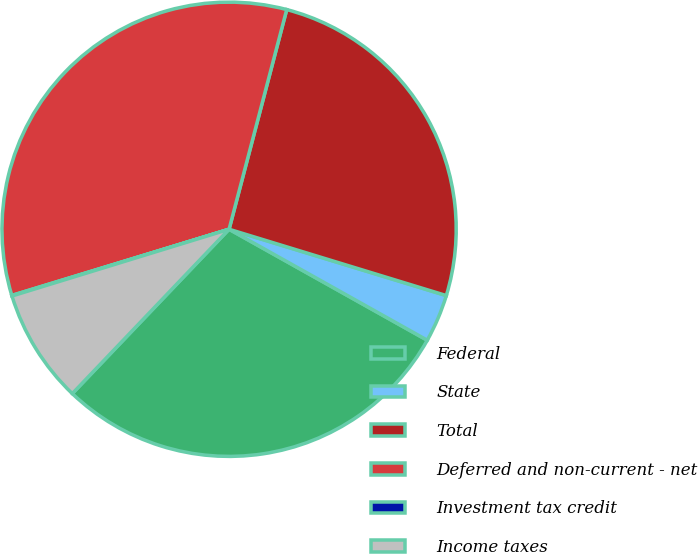Convert chart to OTSL. <chart><loc_0><loc_0><loc_500><loc_500><pie_chart><fcel>Federal<fcel>State<fcel>Total<fcel>Deferred and non-current - net<fcel>Investment tax credit<fcel>Income taxes<nl><fcel>29.0%<fcel>3.41%<fcel>25.63%<fcel>33.79%<fcel>0.04%<fcel>8.13%<nl></chart> 